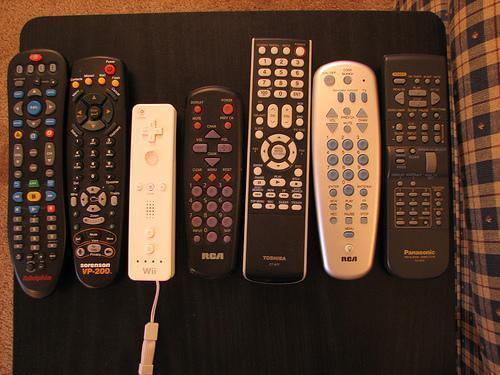How many remote controls are there?
Give a very brief answer. 7. 